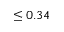Convert formula to latex. <formula><loc_0><loc_0><loc_500><loc_500>\leq 0 . 3 4</formula> 